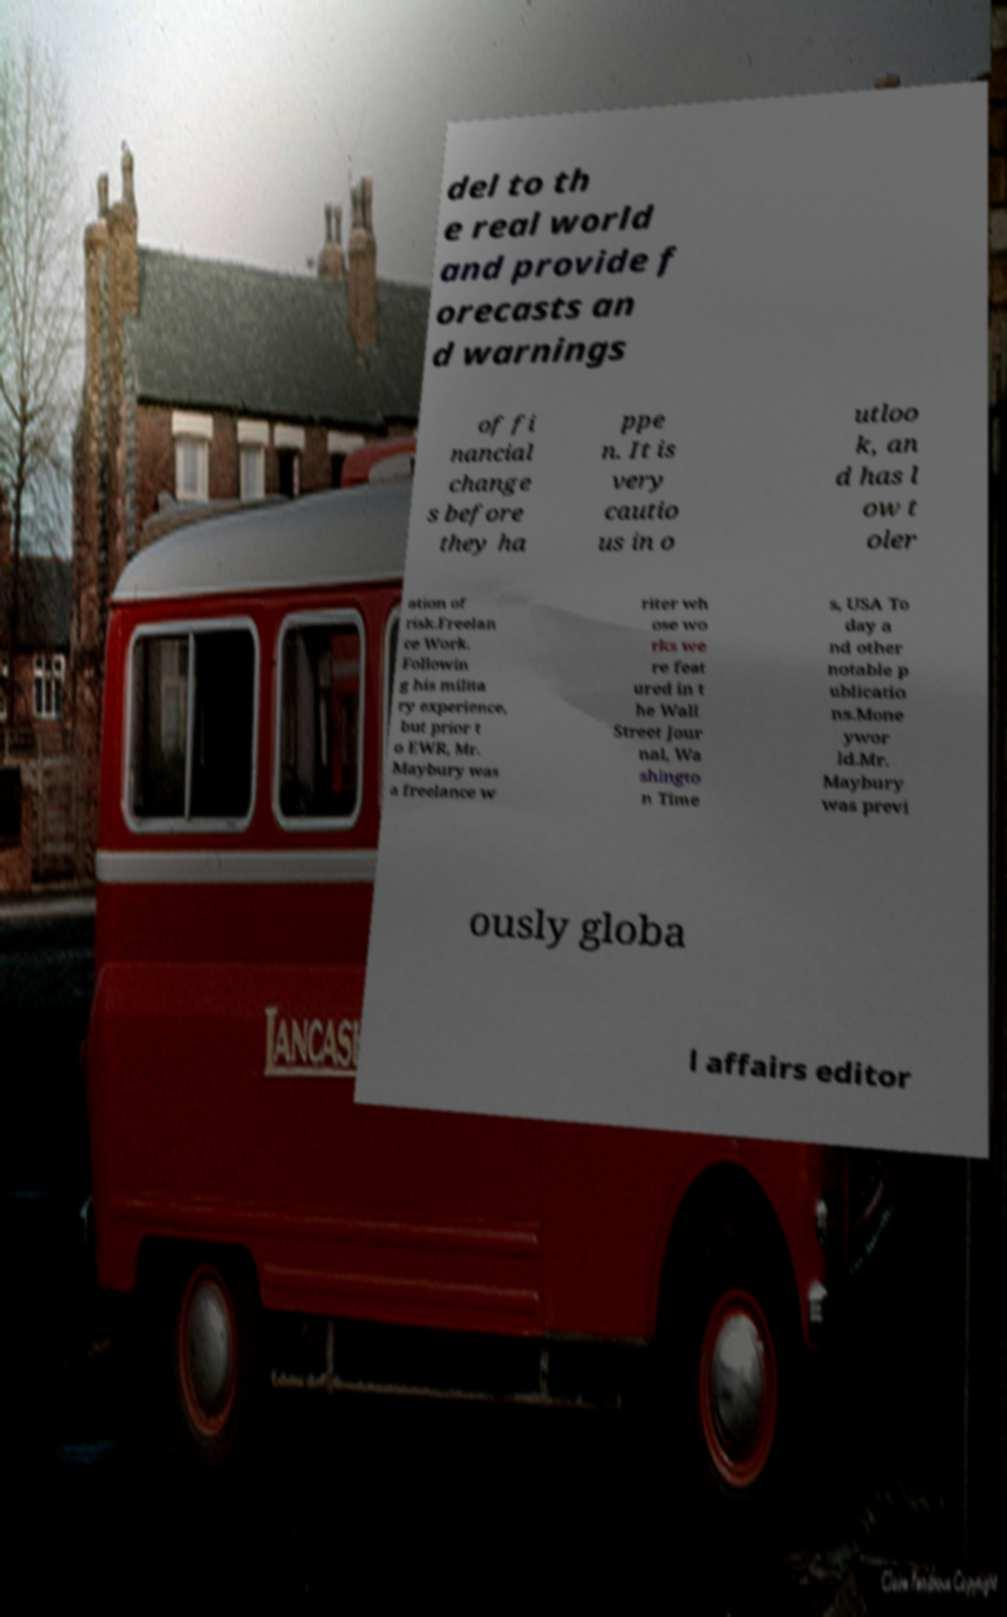There's text embedded in this image that I need extracted. Can you transcribe it verbatim? del to th e real world and provide f orecasts an d warnings of fi nancial change s before they ha ppe n. It is very cautio us in o utloo k, an d has l ow t oler ation of risk.Freelan ce Work. Followin g his milita ry experience, but prior t o EWR, Mr. Maybury was a freelance w riter wh ose wo rks we re feat ured in t he Wall Street Jour nal, Wa shingto n Time s, USA To day a nd other notable p ublicatio ns.Mone ywor ld.Mr. Maybury was previ ously globa l affairs editor 